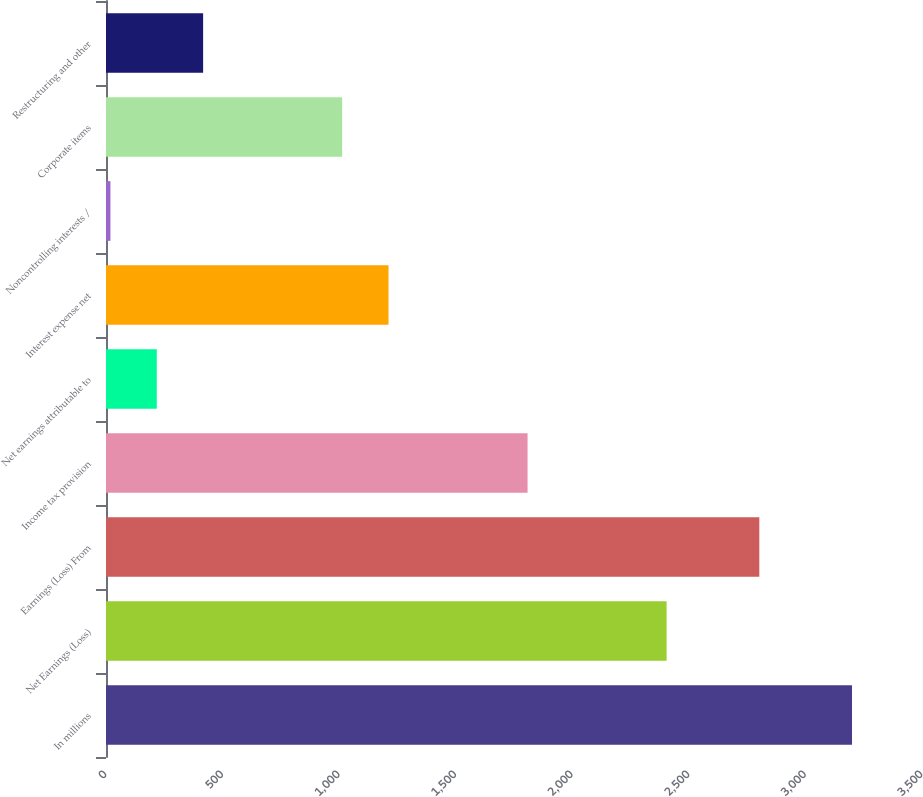Convert chart. <chart><loc_0><loc_0><loc_500><loc_500><bar_chart><fcel>In millions<fcel>Net Earnings (Loss)<fcel>Earnings (Loss) From<fcel>Income tax provision<fcel>Net earnings attributable to<fcel>Interest expense net<fcel>Noncontrolling interests /<fcel>Corporate items<fcel>Restructuring and other<nl><fcel>3199.8<fcel>2404.6<fcel>2802.2<fcel>1808.2<fcel>217.8<fcel>1211.8<fcel>19<fcel>1013<fcel>416.6<nl></chart> 